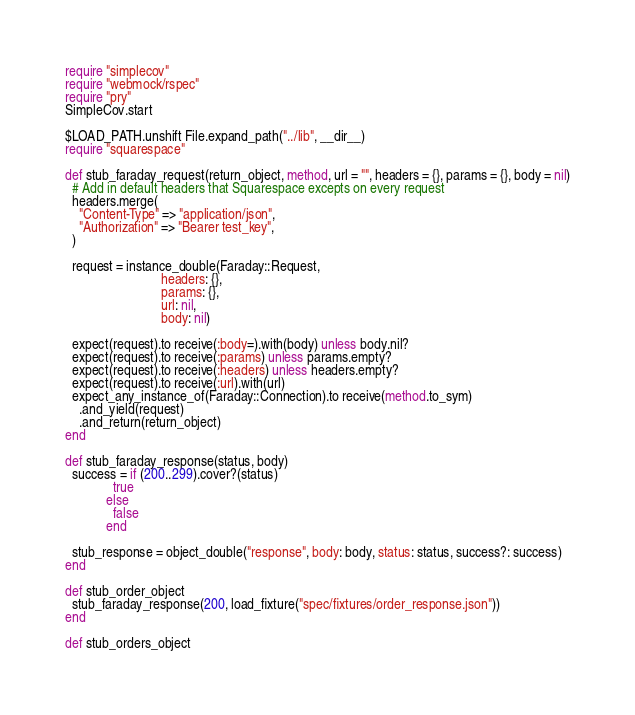Convert code to text. <code><loc_0><loc_0><loc_500><loc_500><_Ruby_>require "simplecov"
require "webmock/rspec"
require "pry"
SimpleCov.start

$LOAD_PATH.unshift File.expand_path("../lib", __dir__)
require "squarespace"

def stub_faraday_request(return_object, method, url = "", headers = {}, params = {}, body = nil)
  # Add in default headers that Squarespace excepts on every request
  headers.merge(
    "Content-Type" => "application/json",
    "Authorization" => "Bearer test_key",
  )

  request = instance_double(Faraday::Request,
                            headers: {},
                            params: {},
                            url: nil,
                            body: nil)

  expect(request).to receive(:body=).with(body) unless body.nil?
  expect(request).to receive(:params) unless params.empty?
  expect(request).to receive(:headers) unless headers.empty?
  expect(request).to receive(:url).with(url)
  expect_any_instance_of(Faraday::Connection).to receive(method.to_sym)
    .and_yield(request)
    .and_return(return_object)
end

def stub_faraday_response(status, body)
  success = if (200..299).cover?(status)
              true
            else
              false
            end

  stub_response = object_double("response", body: body, status: status, success?: success)
end

def stub_order_object
  stub_faraday_response(200, load_fixture("spec/fixtures/order_response.json"))
end

def stub_orders_object</code> 